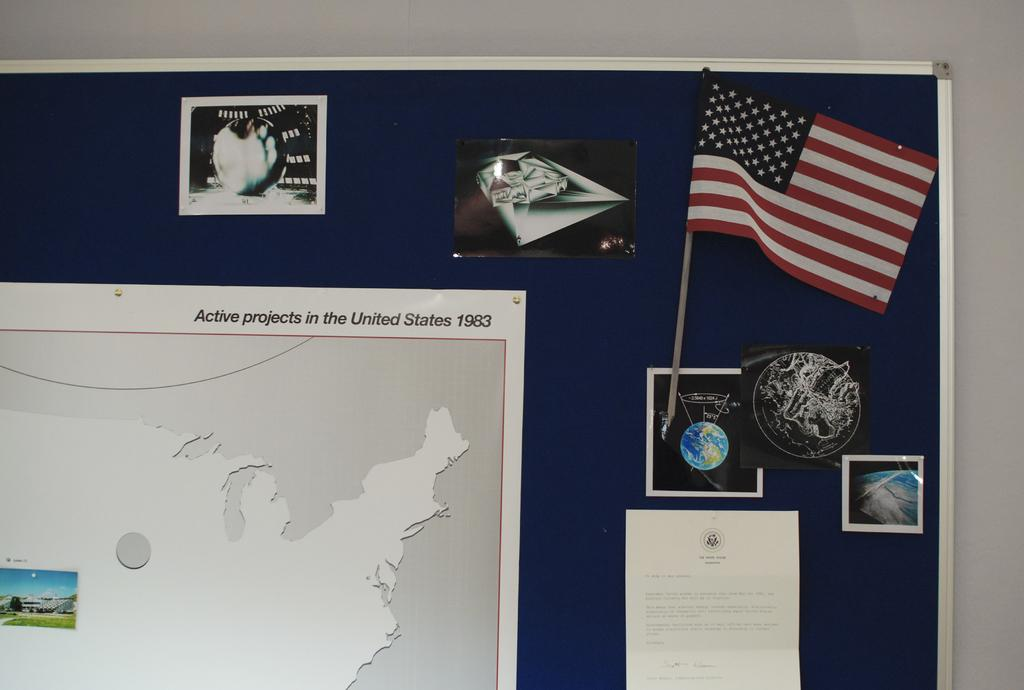What is on the wall in the image? There is a board on the wall in the image. What is attached to the board? There are posters with text and images attached to the board. Can you describe the flag in the image? There is a flag in the image, but no specific details about the flag are provided. What type of advice can be heard coming from the whistle in the image? There is no whistle present in the image, so it's not possible to determine what, if any, advice might be heard. What color is the sock on the flag in the image? There is no sock present in the image, and the flag itself is not described in enough detail to determine the presence or absence of a sock. 